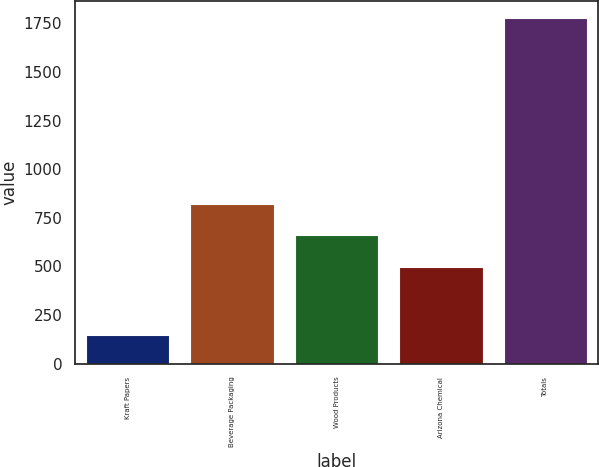Convert chart to OTSL. <chart><loc_0><loc_0><loc_500><loc_500><bar_chart><fcel>Kraft Papers<fcel>Beverage Packaging<fcel>Wood Products<fcel>Arizona Chemical<fcel>Totals<nl><fcel>148<fcel>822<fcel>659<fcel>496<fcel>1778<nl></chart> 